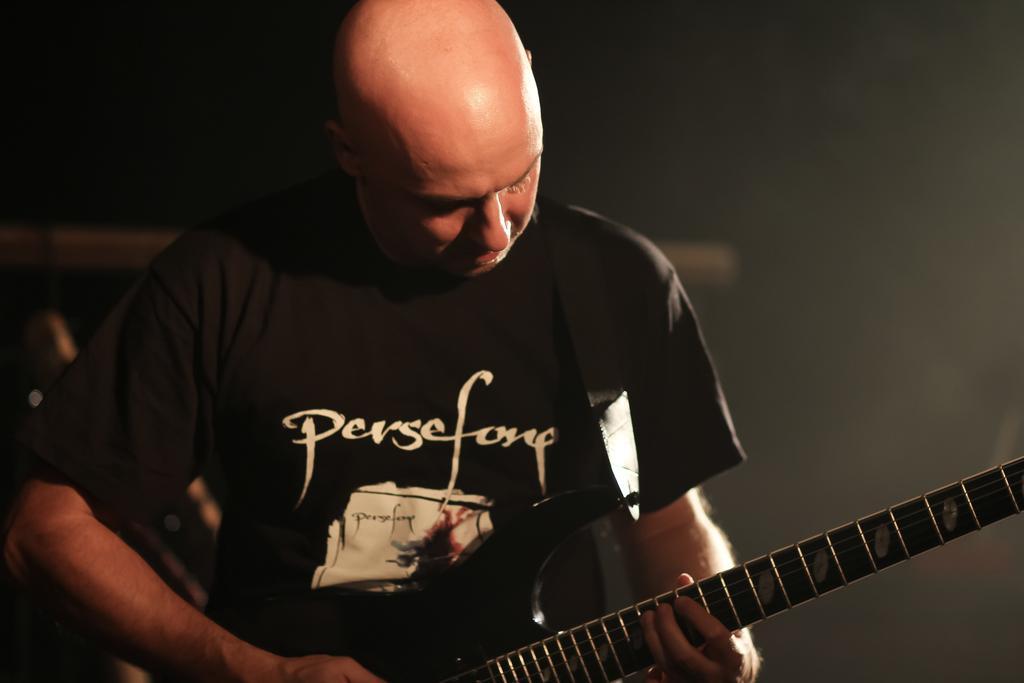Can you describe this image briefly? There is a man in the given picture, holding a guitar in his hands. He is wearing the black shirt. In the background, there is a wall. 